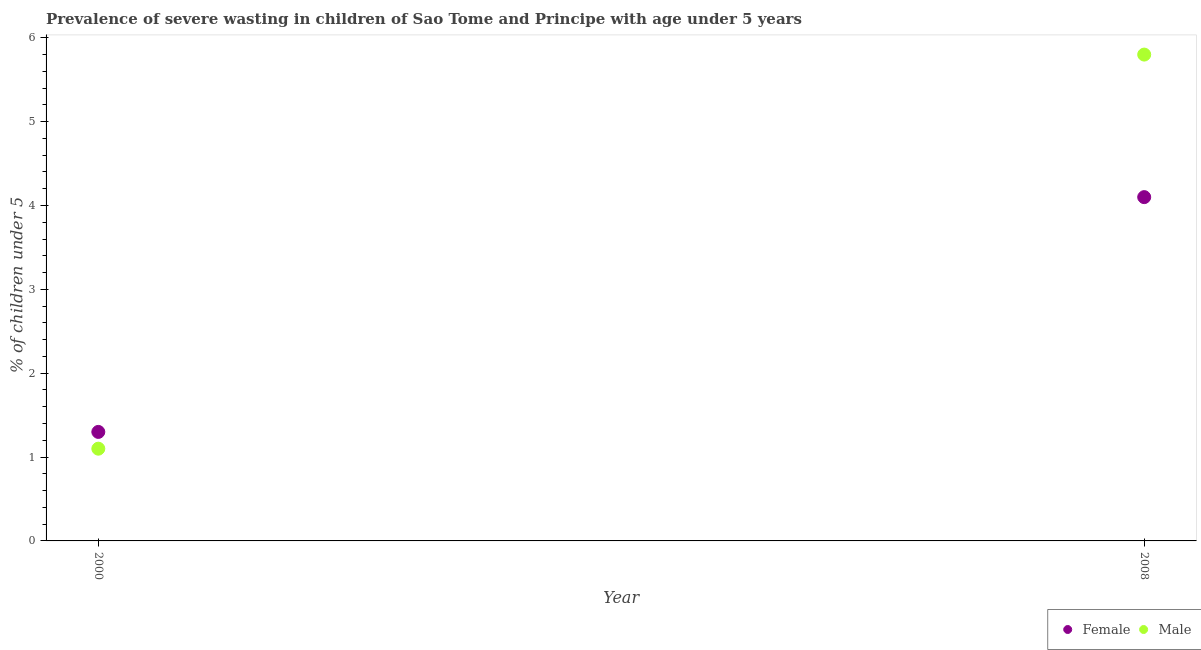How many different coloured dotlines are there?
Keep it short and to the point. 2. What is the percentage of undernourished male children in 2000?
Keep it short and to the point. 1.1. Across all years, what is the maximum percentage of undernourished male children?
Provide a succinct answer. 5.8. Across all years, what is the minimum percentage of undernourished male children?
Give a very brief answer. 1.1. In which year was the percentage of undernourished male children minimum?
Give a very brief answer. 2000. What is the total percentage of undernourished male children in the graph?
Keep it short and to the point. 6.9. What is the difference between the percentage of undernourished female children in 2000 and that in 2008?
Give a very brief answer. -2.8. What is the difference between the percentage of undernourished male children in 2000 and the percentage of undernourished female children in 2008?
Your response must be concise. -3. What is the average percentage of undernourished male children per year?
Offer a terse response. 3.45. In the year 2000, what is the difference between the percentage of undernourished male children and percentage of undernourished female children?
Your answer should be compact. -0.2. What is the ratio of the percentage of undernourished male children in 2000 to that in 2008?
Provide a short and direct response. 0.19. Is the percentage of undernourished female children in 2000 less than that in 2008?
Your answer should be compact. Yes. Does the percentage of undernourished male children monotonically increase over the years?
Your answer should be compact. Yes. How many years are there in the graph?
Make the answer very short. 2. Are the values on the major ticks of Y-axis written in scientific E-notation?
Offer a very short reply. No. Does the graph contain any zero values?
Provide a short and direct response. No. Does the graph contain grids?
Make the answer very short. No. How are the legend labels stacked?
Give a very brief answer. Horizontal. What is the title of the graph?
Your answer should be very brief. Prevalence of severe wasting in children of Sao Tome and Principe with age under 5 years. What is the label or title of the Y-axis?
Offer a terse response.  % of children under 5. What is the  % of children under 5 of Female in 2000?
Offer a very short reply. 1.3. What is the  % of children under 5 of Male in 2000?
Your answer should be very brief. 1.1. What is the  % of children under 5 in Female in 2008?
Give a very brief answer. 4.1. What is the  % of children under 5 of Male in 2008?
Offer a very short reply. 5.8. Across all years, what is the maximum  % of children under 5 in Female?
Keep it short and to the point. 4.1. Across all years, what is the maximum  % of children under 5 of Male?
Provide a short and direct response. 5.8. Across all years, what is the minimum  % of children under 5 of Female?
Offer a very short reply. 1.3. Across all years, what is the minimum  % of children under 5 in Male?
Your response must be concise. 1.1. What is the total  % of children under 5 of Female in the graph?
Offer a terse response. 5.4. What is the total  % of children under 5 in Male in the graph?
Provide a short and direct response. 6.9. What is the difference between the  % of children under 5 in Female in 2000 and the  % of children under 5 in Male in 2008?
Offer a terse response. -4.5. What is the average  % of children under 5 in Male per year?
Your response must be concise. 3.45. What is the ratio of the  % of children under 5 of Female in 2000 to that in 2008?
Ensure brevity in your answer.  0.32. What is the ratio of the  % of children under 5 of Male in 2000 to that in 2008?
Make the answer very short. 0.19. What is the difference between the highest and the second highest  % of children under 5 of Female?
Ensure brevity in your answer.  2.8. What is the difference between the highest and the lowest  % of children under 5 in Female?
Your answer should be compact. 2.8. What is the difference between the highest and the lowest  % of children under 5 of Male?
Keep it short and to the point. 4.7. 